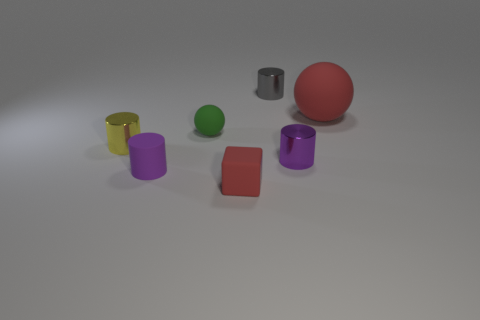Subtract all small yellow metallic cylinders. How many cylinders are left? 3 Subtract all blue blocks. How many gray cylinders are left? 1 Subtract all tiny gray cylinders. Subtract all small yellow objects. How many objects are left? 5 Add 1 purple cylinders. How many purple cylinders are left? 3 Add 3 green matte balls. How many green matte balls exist? 4 Add 1 red blocks. How many objects exist? 8 Subtract all gray cylinders. How many cylinders are left? 3 Subtract 0 cyan spheres. How many objects are left? 7 Subtract all cylinders. How many objects are left? 3 Subtract 3 cylinders. How many cylinders are left? 1 